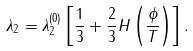<formula> <loc_0><loc_0><loc_500><loc_500>\lambda _ { 2 } = \lambda ^ { ( 0 ) } _ { 2 } \left [ \frac { 1 } { 3 } + \frac { 2 } { 3 } H \left ( \frac { \phi } { T } \right ) \right ] .</formula> 